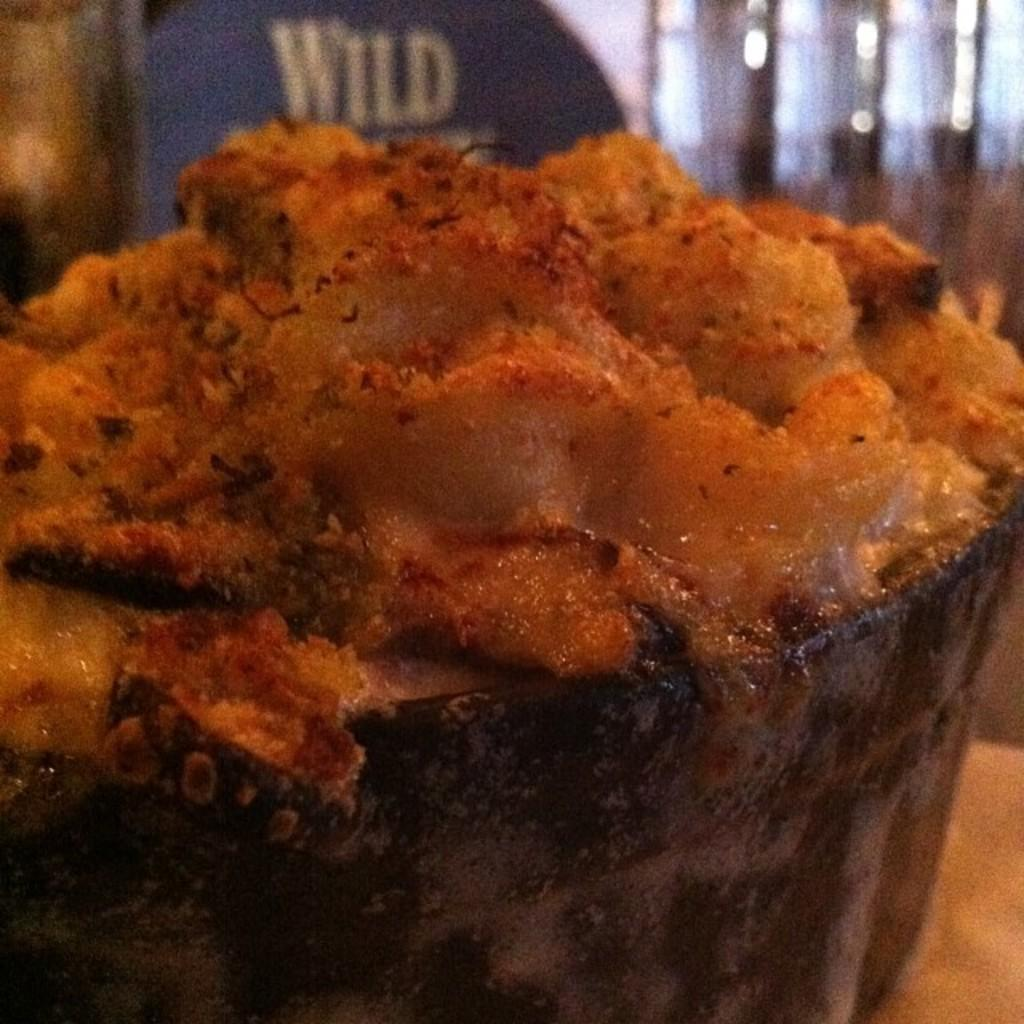What is on the table in the image? There is food placed on the table in the image. Can you describe the background of the image? The background of the image is blurry. What color is the stocking hanging on the wall in the image? There is no stocking hanging on the wall in the image; it only features food on the table and a blurry background. 